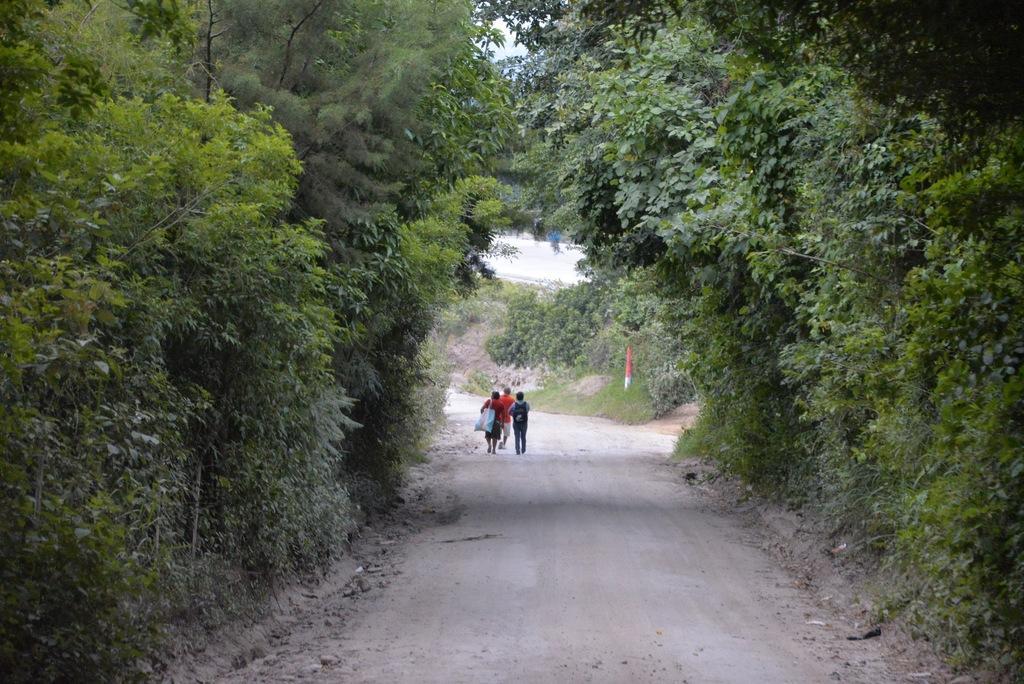Can you describe this image briefly? In this image in the center there are three people who are wearing bags and walking, and on the right side and left side there are some trees. At the bottom there is walkway and in the background there are some trees, pole, grass and some object. 